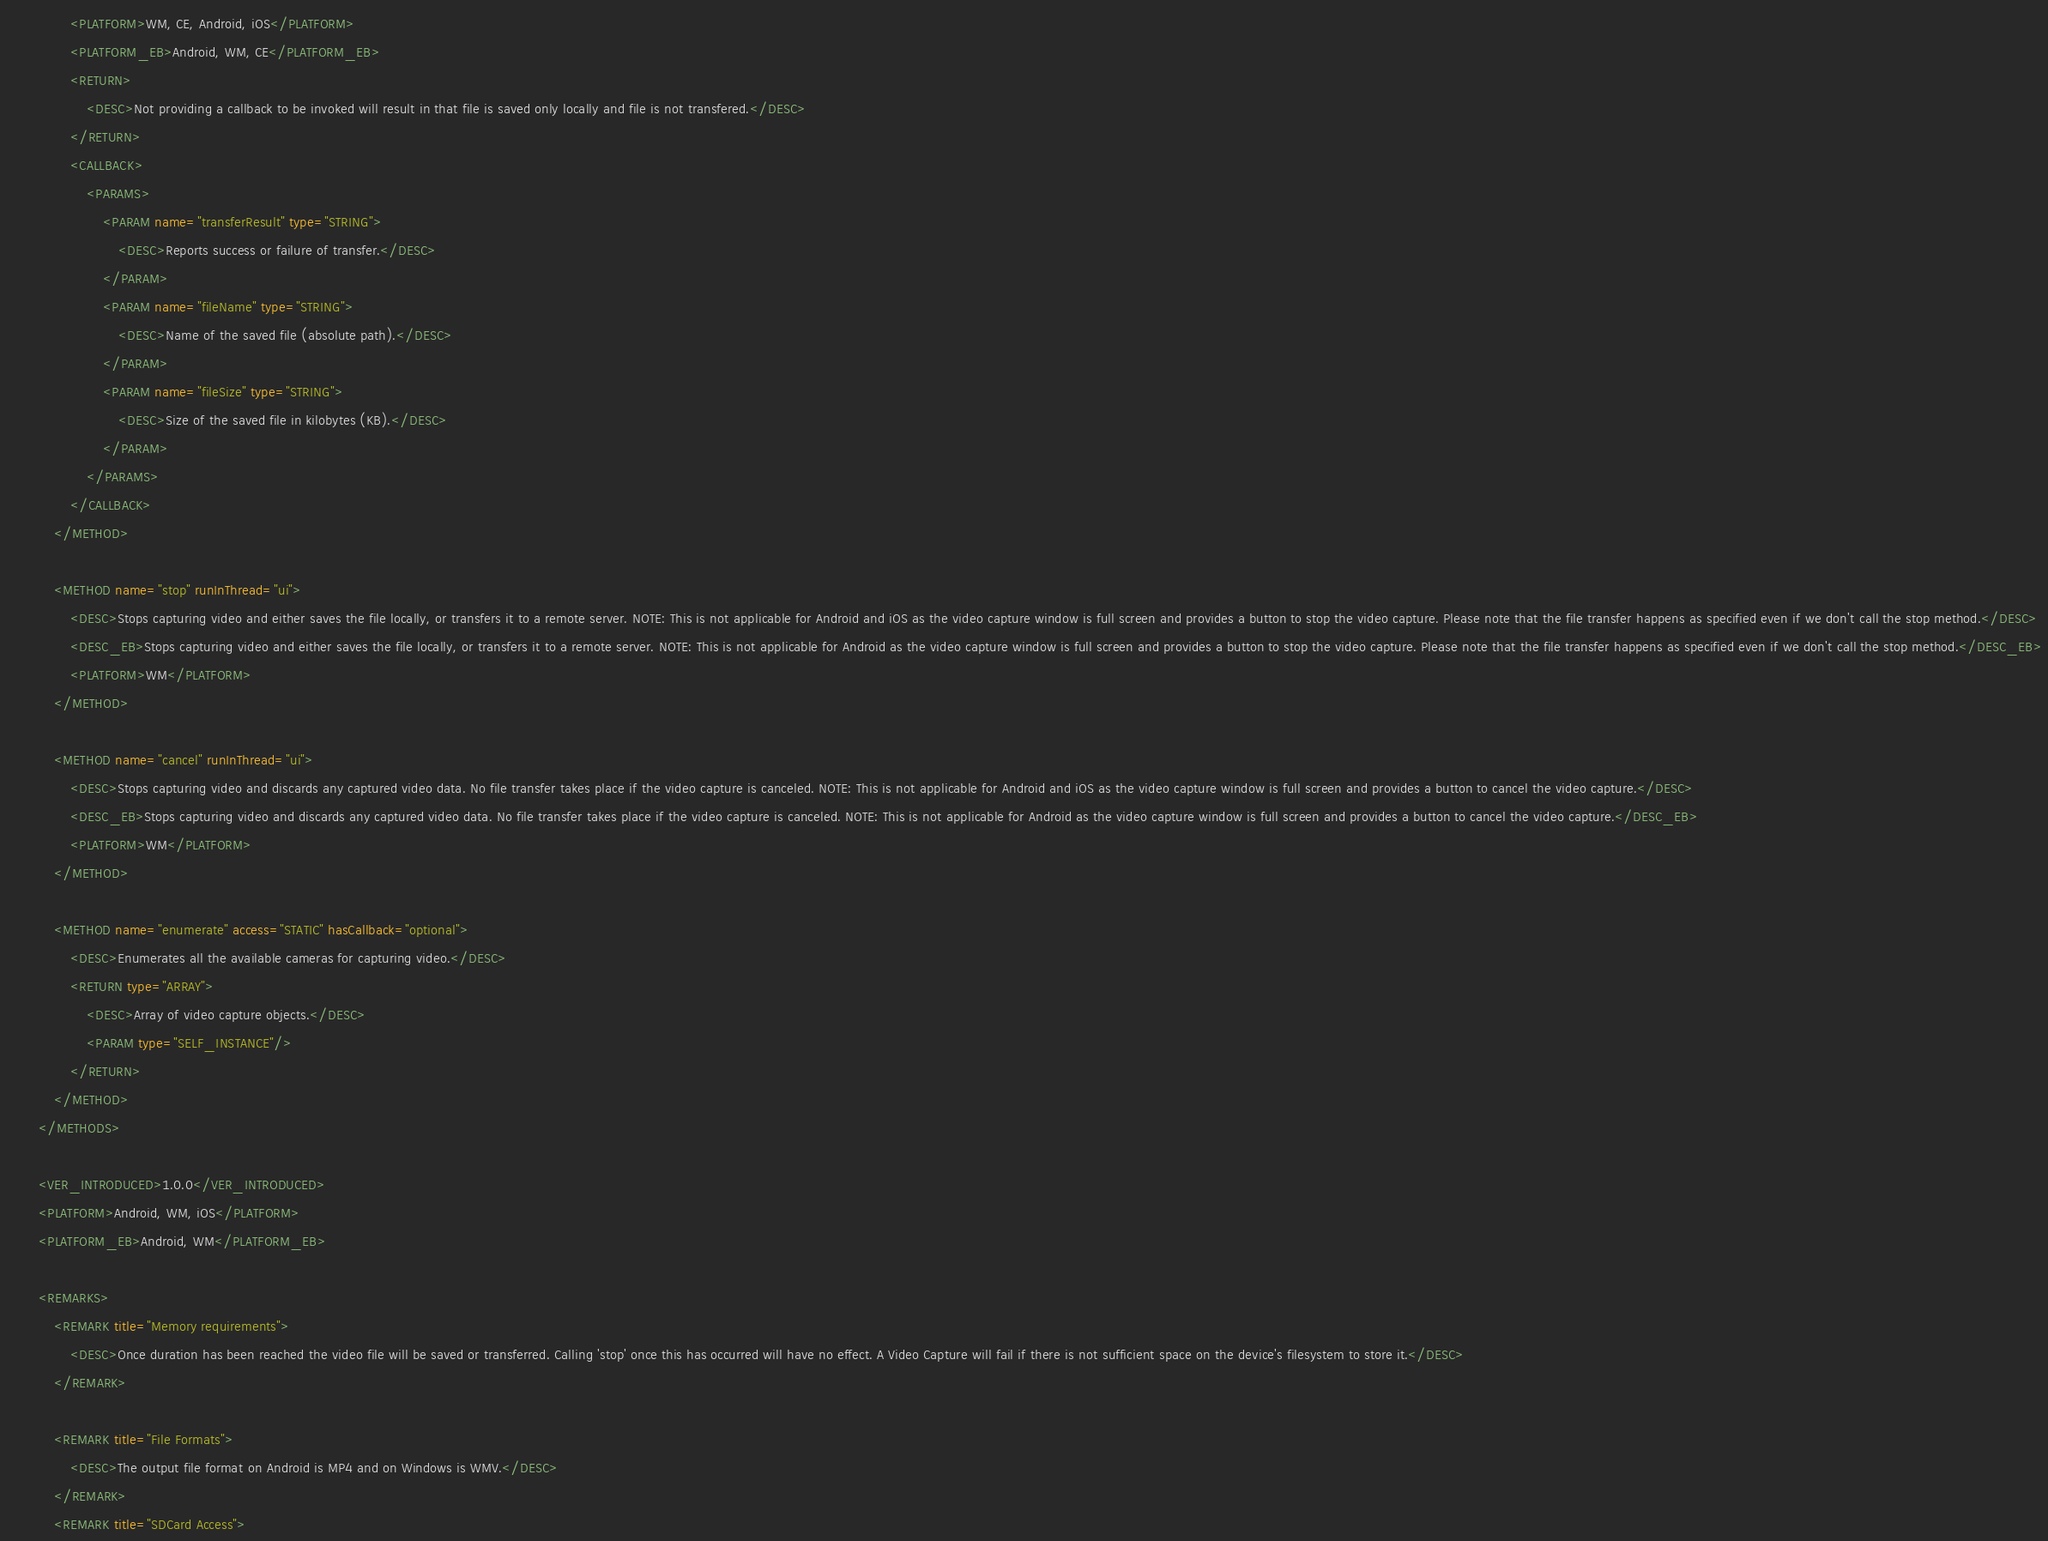Convert code to text. <code><loc_0><loc_0><loc_500><loc_500><_XML_>                <PLATFORM>WM, CE, Android, iOS</PLATFORM>
                <PLATFORM_EB>Android, WM, CE</PLATFORM_EB>
                <RETURN>
                    <DESC>Not providing a callback to be invoked will result in that file is saved only locally and file is not transfered.</DESC>
                </RETURN>
                <CALLBACK>
                    <PARAMS>
                        <PARAM name="transferResult" type="STRING">
                            <DESC>Reports success or failure of transfer.</DESC>
                        </PARAM>
                        <PARAM name="fileName" type="STRING">
                            <DESC>Name of the saved file (absolute path).</DESC>
                        </PARAM>
                        <PARAM name="fileSize" type="STRING">
                            <DESC>Size of the saved file in kilobytes (KB).</DESC>
                        </PARAM>
                    </PARAMS>
                </CALLBACK>
            </METHOD>

            <METHOD name="stop" runInThread="ui">
                <DESC>Stops capturing video and either saves the file locally, or transfers it to a remote server. NOTE: This is not applicable for Android and iOS as the video capture window is full screen and provides a button to stop the video capture. Please note that the file transfer happens as specified even if we don't call the stop method.</DESC>
                <DESC_EB>Stops capturing video and either saves the file locally, or transfers it to a remote server. NOTE: This is not applicable for Android as the video capture window is full screen and provides a button to stop the video capture. Please note that the file transfer happens as specified even if we don't call the stop method.</DESC_EB>
                <PLATFORM>WM</PLATFORM>
            </METHOD>

            <METHOD name="cancel" runInThread="ui">
                <DESC>Stops capturing video and discards any captured video data. No file transfer takes place if the video capture is canceled. NOTE: This is not applicable for Android and iOS as the video capture window is full screen and provides a button to cancel the video capture.</DESC>
                <DESC_EB>Stops capturing video and discards any captured video data. No file transfer takes place if the video capture is canceled. NOTE: This is not applicable for Android as the video capture window is full screen and provides a button to cancel the video capture.</DESC_EB>
                <PLATFORM>WM</PLATFORM>
            </METHOD>

            <METHOD name="enumerate" access="STATIC" hasCallback="optional">
                <DESC>Enumerates all the available cameras for capturing video.</DESC>
                <RETURN type="ARRAY">
                    <DESC>Array of video capture objects.</DESC>
                    <PARAM type="SELF_INSTANCE"/>
                </RETURN>
            </METHOD>
        </METHODS>

        <VER_INTRODUCED>1.0.0</VER_INTRODUCED>
        <PLATFORM>Android, WM, iOS</PLATFORM>
        <PLATFORM_EB>Android, WM</PLATFORM_EB>

        <REMARKS>
            <REMARK title="Memory requirements">
                <DESC>Once duration has been reached the video file will be saved or transferred. Calling 'stop' once this has occurred will have no effect. A Video Capture will fail if there is not sufficient space on the device's filesystem to store it.</DESC>
            </REMARK>

            <REMARK title="File Formats">
                <DESC>The output file format on Android is MP4 and on Windows is WMV.</DESC>
            </REMARK>
            <REMARK title="SDCard Access"></code> 